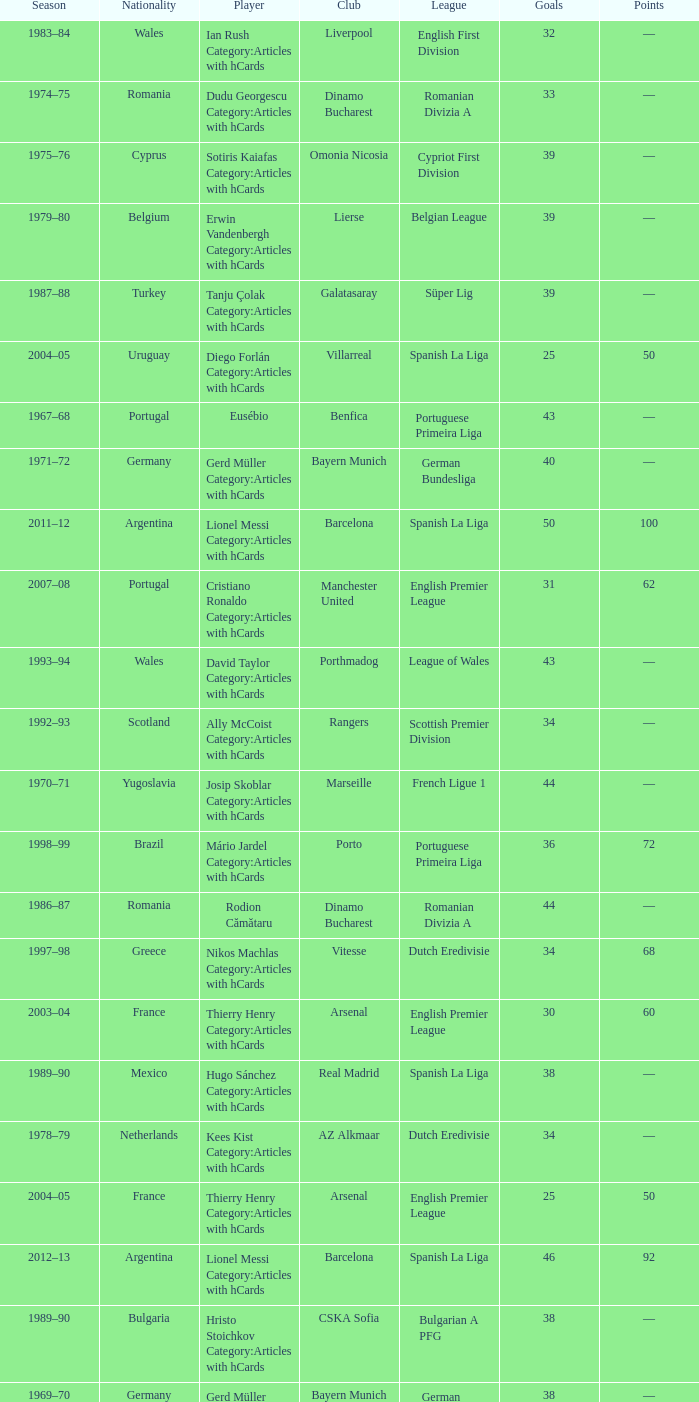Which player was in the Omonia Nicosia club? Sotiris Kaiafas Category:Articles with hCards. 